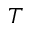<formula> <loc_0><loc_0><loc_500><loc_500>T</formula> 